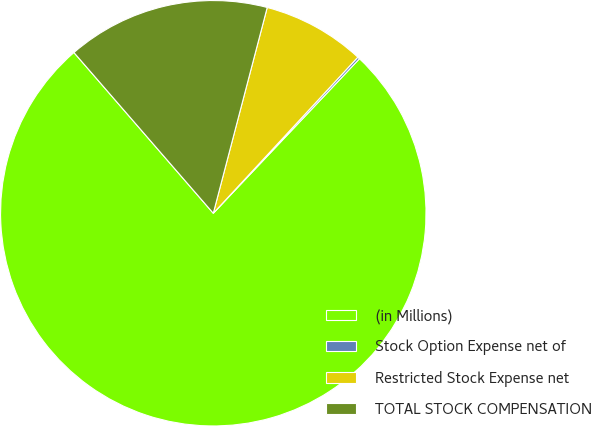Convert chart. <chart><loc_0><loc_0><loc_500><loc_500><pie_chart><fcel>(in Millions)<fcel>Stock Option Expense net of<fcel>Restricted Stock Expense net<fcel>TOTAL STOCK COMPENSATION<nl><fcel>76.58%<fcel>0.17%<fcel>7.81%<fcel>15.45%<nl></chart> 